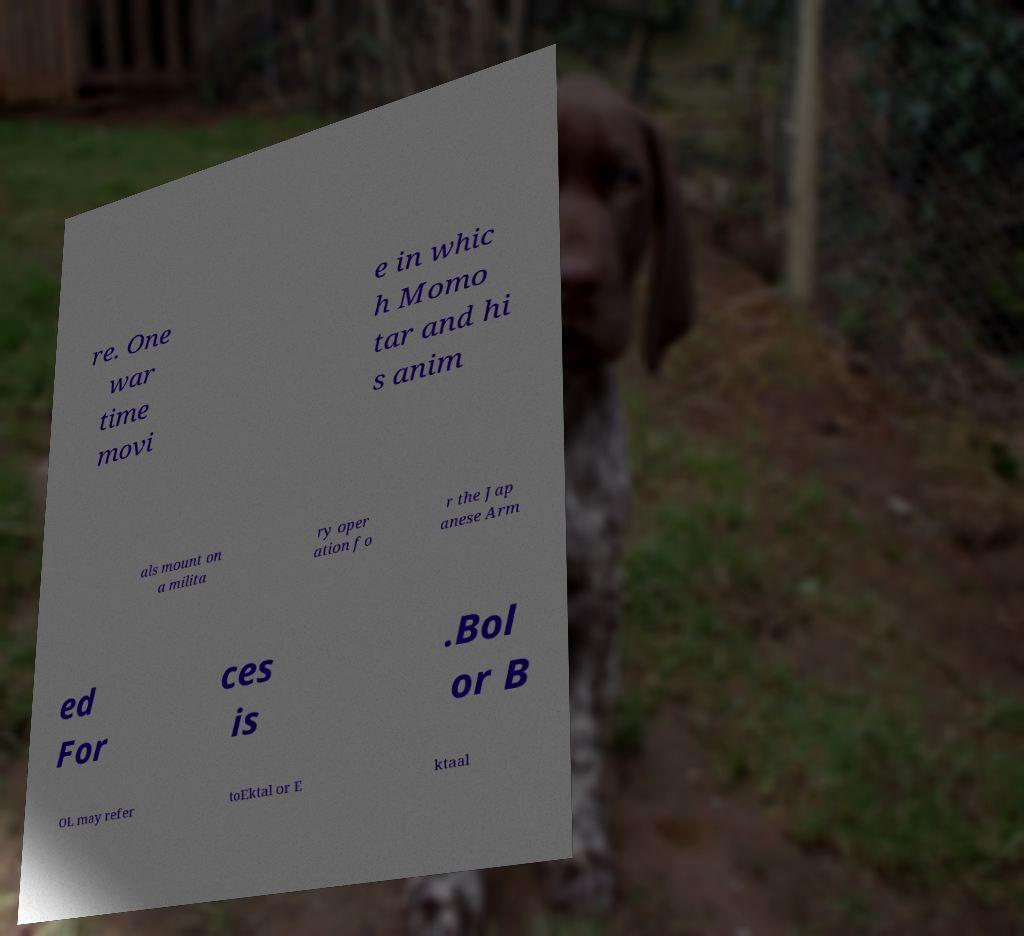Could you assist in decoding the text presented in this image and type it out clearly? re. One war time movi e in whic h Momo tar and hi s anim als mount on a milita ry oper ation fo r the Jap anese Arm ed For ces is .Bol or B OL may refer toEktal or E ktaal 